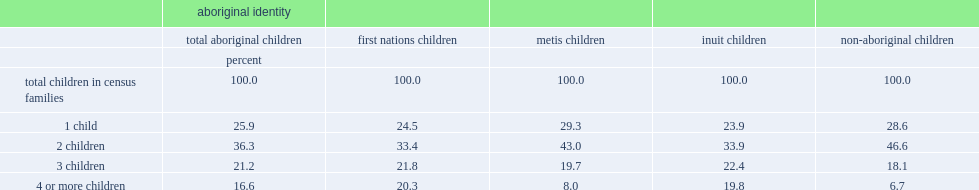In 2011, what was the percent of aboriginal children aged 14 and under lived in a family with four or more children in the same age group? 16.6. In 2011, what was the percent of non-aboriginal children aged 14 and under lived in a family with four or more children in the same age group? 6.7. In 2011, what was the percent of both first nations and inuit children aged 14 and under lived in a family with four or more children in the same age group? 20.3. In 2011, what was the percent of metis children aged 14 and under lived in a family with four or more children in the same age group? 8.0. 